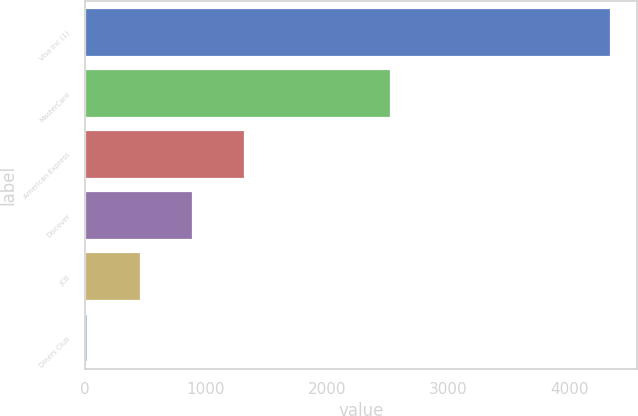Convert chart. <chart><loc_0><loc_0><loc_500><loc_500><bar_chart><fcel>Visa Inc (1)<fcel>MasterCard<fcel>American Express<fcel>Discover<fcel>JCB<fcel>Diners Club<nl><fcel>4346<fcel>2533<fcel>1325.5<fcel>894<fcel>462.5<fcel>31<nl></chart> 